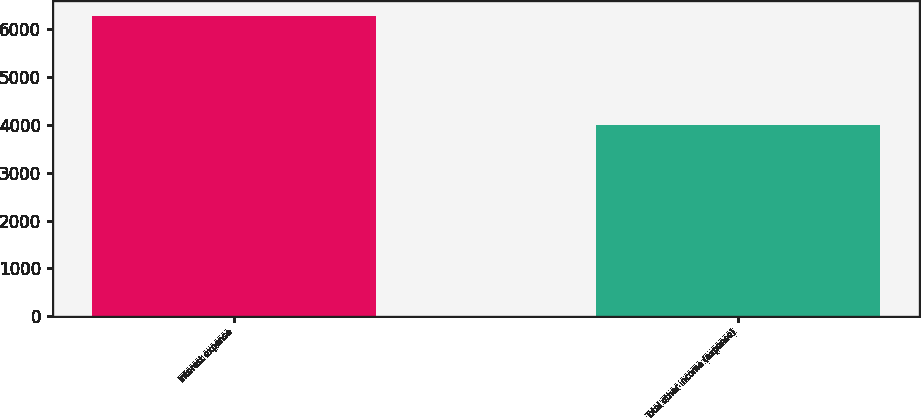Convert chart to OTSL. <chart><loc_0><loc_0><loc_500><loc_500><bar_chart><fcel>Interest expense<fcel>Total other income (expense)<nl><fcel>6280<fcel>4005<nl></chart> 